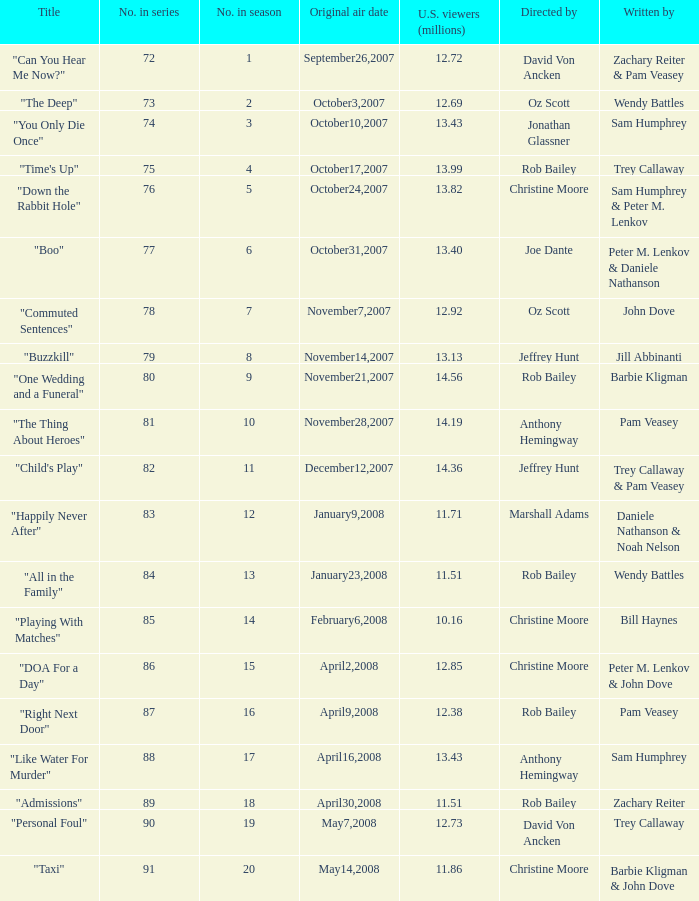How many episodes were watched by 12.72 million U.S. viewers? 1.0. 